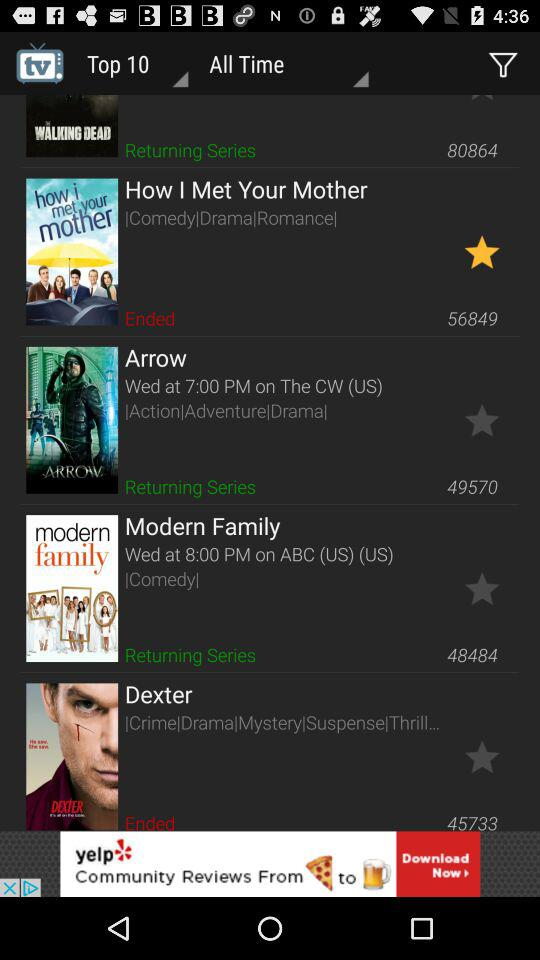What are the genres of "Arrow" series? The genres of "Arrow" series are action, adventure and drama. 